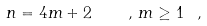Convert formula to latex. <formula><loc_0><loc_0><loc_500><loc_500>n = 4 m + 2 \quad , \, m \geq 1 \ ,</formula> 